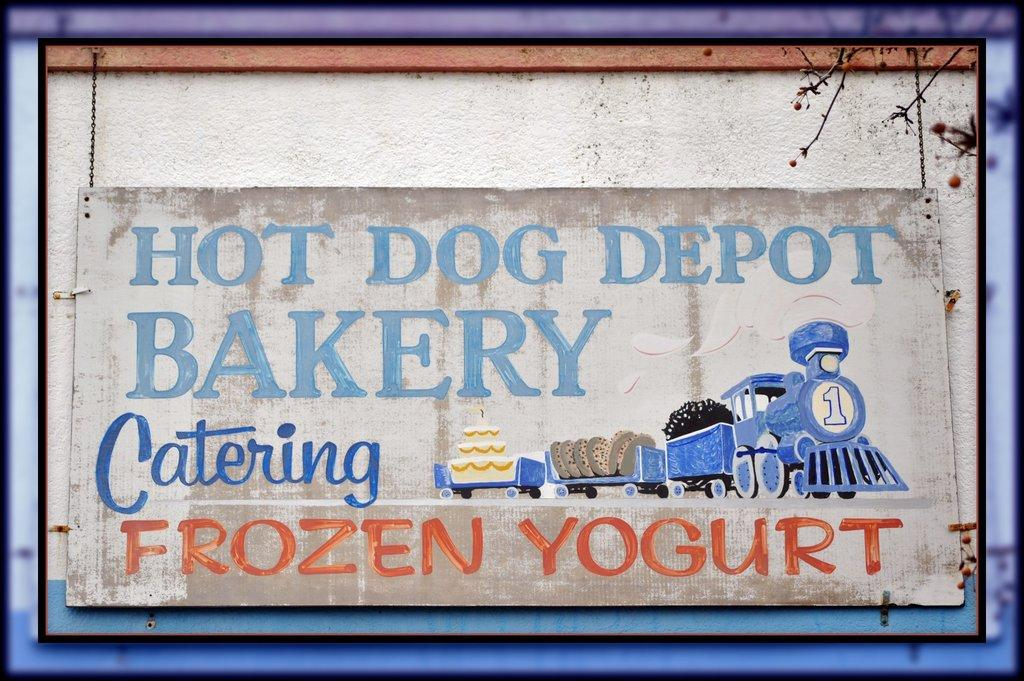What is the main object in the image? There is a board in the image. What is depicted on the board? The board has a painting of a train. Are there any words or phrases on the board? Yes, there is writing on the board. What can be seen to the right of the board in the image? There is a tree to the right of the board in the image. What type of current is flowing through the shelf in the image? There is no shelf present in the image, and therefore no current can be flowing through it. 